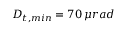<formula> <loc_0><loc_0><loc_500><loc_500>D _ { t , \min } = 7 0 \, \mu r a d</formula> 